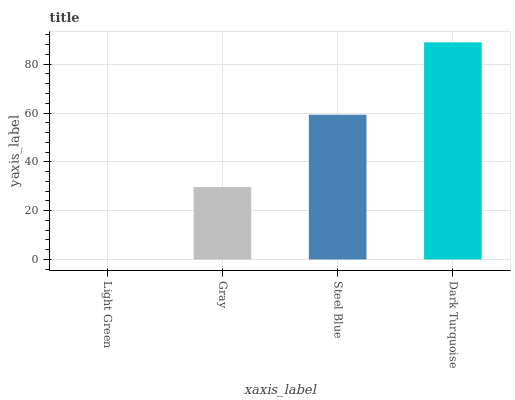Is Light Green the minimum?
Answer yes or no. Yes. Is Dark Turquoise the maximum?
Answer yes or no. Yes. Is Gray the minimum?
Answer yes or no. No. Is Gray the maximum?
Answer yes or no. No. Is Gray greater than Light Green?
Answer yes or no. Yes. Is Light Green less than Gray?
Answer yes or no. Yes. Is Light Green greater than Gray?
Answer yes or no. No. Is Gray less than Light Green?
Answer yes or no. No. Is Steel Blue the high median?
Answer yes or no. Yes. Is Gray the low median?
Answer yes or no. Yes. Is Gray the high median?
Answer yes or no. No. Is Dark Turquoise the low median?
Answer yes or no. No. 